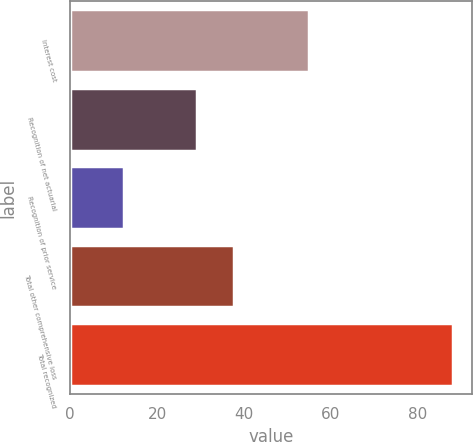<chart> <loc_0><loc_0><loc_500><loc_500><bar_chart><fcel>Interest cost<fcel>Recognition of net actuarial<fcel>Recognition of prior service<fcel>Total other comprehensive loss<fcel>Total recognized<nl><fcel>55<fcel>29.2<fcel>12.4<fcel>37.6<fcel>88<nl></chart> 